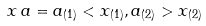<formula> <loc_0><loc_0><loc_500><loc_500>x \, a = a _ { ( 1 ) } < x _ { ( 1 ) } , a _ { ( 2 ) } > x _ { ( 2 ) }</formula> 